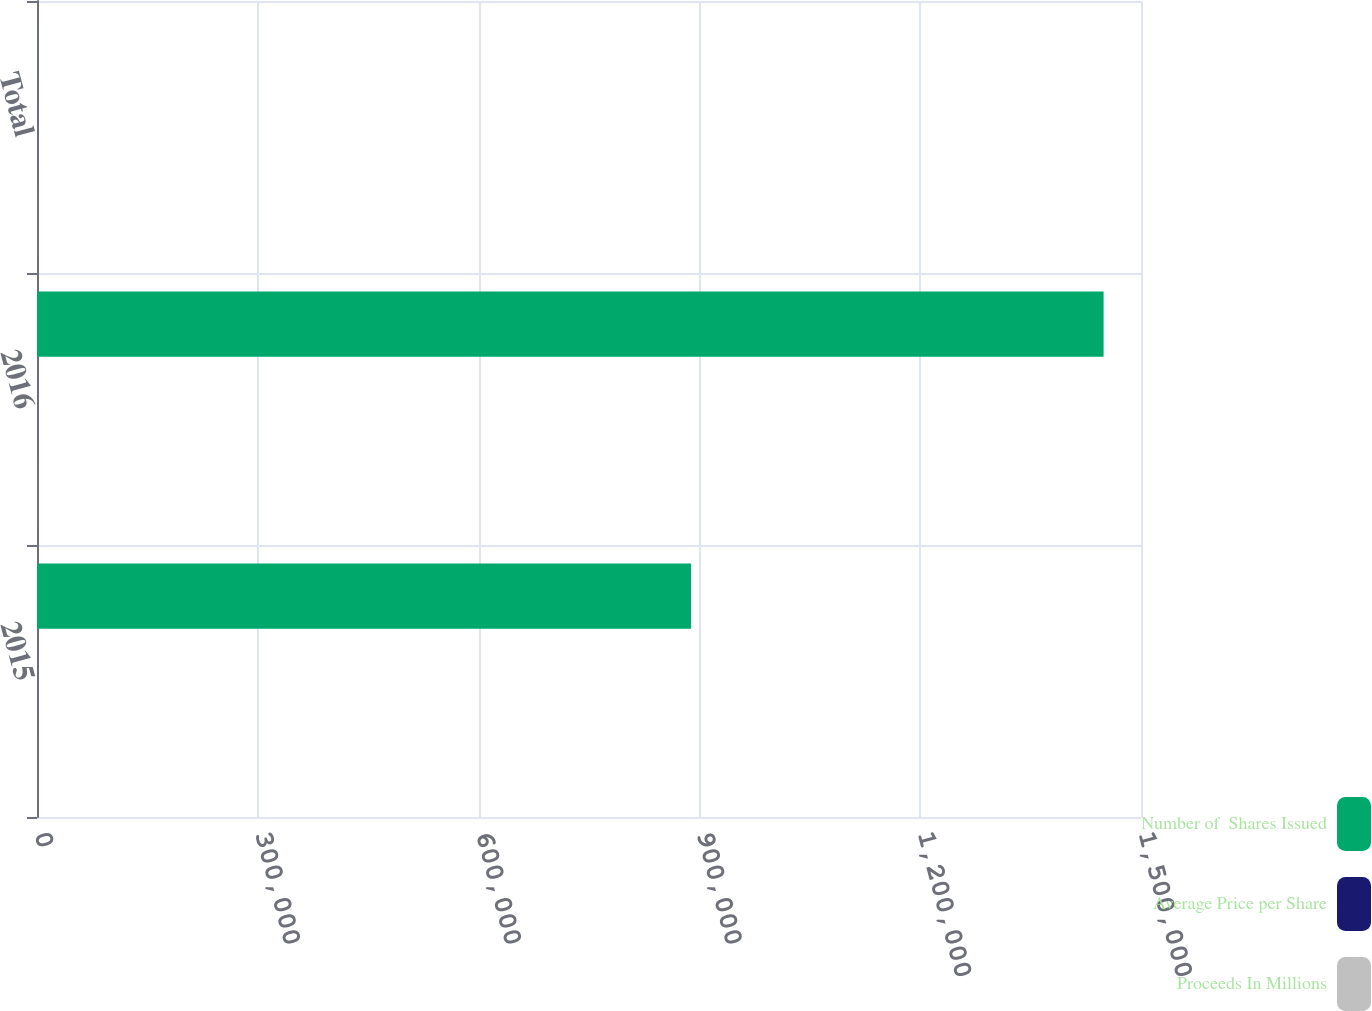<chart> <loc_0><loc_0><loc_500><loc_500><stacked_bar_chart><ecel><fcel>2015<fcel>2016<fcel>Total<nl><fcel>Number of  Shares Issued<fcel>888610<fcel>1.44917e+06<fcel>50.7<nl><fcel>Average Price per Share<fcel>33.76<fcel>41.4<fcel>38.5<nl><fcel>Proceeds In Millions<fcel>30<fcel>60<fcel>90<nl></chart> 